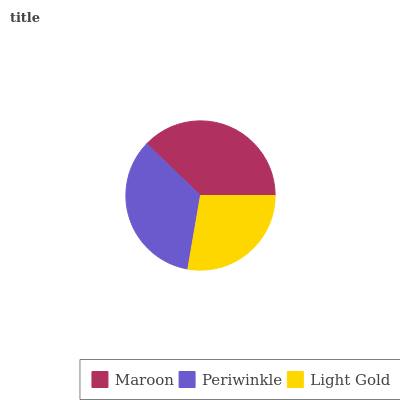Is Light Gold the minimum?
Answer yes or no. Yes. Is Maroon the maximum?
Answer yes or no. Yes. Is Periwinkle the minimum?
Answer yes or no. No. Is Periwinkle the maximum?
Answer yes or no. No. Is Maroon greater than Periwinkle?
Answer yes or no. Yes. Is Periwinkle less than Maroon?
Answer yes or no. Yes. Is Periwinkle greater than Maroon?
Answer yes or no. No. Is Maroon less than Periwinkle?
Answer yes or no. No. Is Periwinkle the high median?
Answer yes or no. Yes. Is Periwinkle the low median?
Answer yes or no. Yes. Is Light Gold the high median?
Answer yes or no. No. Is Light Gold the low median?
Answer yes or no. No. 